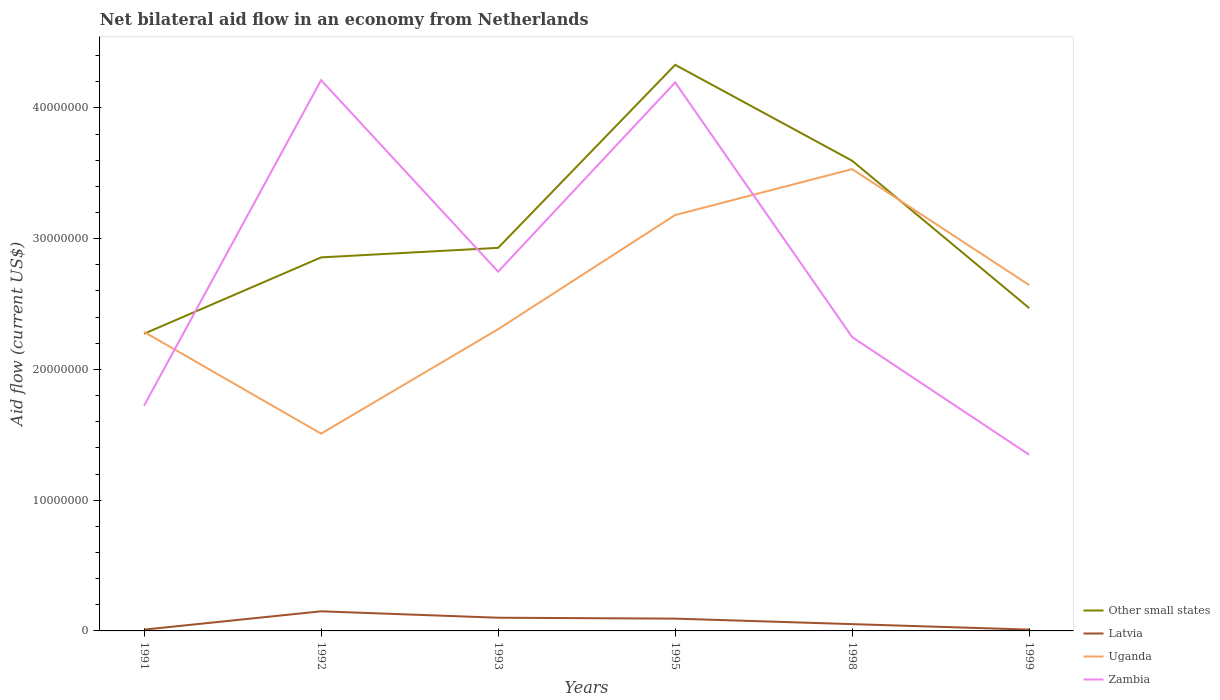Is the number of lines equal to the number of legend labels?
Your answer should be compact. Yes. What is the total net bilateral aid flow in Other small states in the graph?
Your answer should be very brief. -7.30e+05. What is the difference between the highest and the second highest net bilateral aid flow in Zambia?
Give a very brief answer. 2.87e+07. How many years are there in the graph?
Offer a very short reply. 6. Are the values on the major ticks of Y-axis written in scientific E-notation?
Offer a terse response. No. Where does the legend appear in the graph?
Your answer should be compact. Bottom right. How are the legend labels stacked?
Offer a terse response. Vertical. What is the title of the graph?
Ensure brevity in your answer.  Net bilateral aid flow in an economy from Netherlands. Does "Grenada" appear as one of the legend labels in the graph?
Ensure brevity in your answer.  No. What is the label or title of the Y-axis?
Make the answer very short. Aid flow (current US$). What is the Aid flow (current US$) of Other small states in 1991?
Give a very brief answer. 2.27e+07. What is the Aid flow (current US$) in Uganda in 1991?
Offer a terse response. 2.29e+07. What is the Aid flow (current US$) of Zambia in 1991?
Offer a terse response. 1.72e+07. What is the Aid flow (current US$) of Other small states in 1992?
Provide a short and direct response. 2.86e+07. What is the Aid flow (current US$) in Latvia in 1992?
Offer a terse response. 1.50e+06. What is the Aid flow (current US$) of Uganda in 1992?
Your answer should be compact. 1.51e+07. What is the Aid flow (current US$) in Zambia in 1992?
Keep it short and to the point. 4.21e+07. What is the Aid flow (current US$) of Other small states in 1993?
Ensure brevity in your answer.  2.93e+07. What is the Aid flow (current US$) of Latvia in 1993?
Your answer should be very brief. 1.01e+06. What is the Aid flow (current US$) in Uganda in 1993?
Offer a very short reply. 2.31e+07. What is the Aid flow (current US$) in Zambia in 1993?
Your response must be concise. 2.75e+07. What is the Aid flow (current US$) in Other small states in 1995?
Give a very brief answer. 4.33e+07. What is the Aid flow (current US$) in Latvia in 1995?
Your response must be concise. 9.40e+05. What is the Aid flow (current US$) in Uganda in 1995?
Offer a terse response. 3.18e+07. What is the Aid flow (current US$) in Zambia in 1995?
Ensure brevity in your answer.  4.20e+07. What is the Aid flow (current US$) in Other small states in 1998?
Make the answer very short. 3.60e+07. What is the Aid flow (current US$) in Latvia in 1998?
Make the answer very short. 5.20e+05. What is the Aid flow (current US$) in Uganda in 1998?
Offer a terse response. 3.53e+07. What is the Aid flow (current US$) in Zambia in 1998?
Your answer should be compact. 2.25e+07. What is the Aid flow (current US$) of Other small states in 1999?
Offer a terse response. 2.47e+07. What is the Aid flow (current US$) of Latvia in 1999?
Give a very brief answer. 1.00e+05. What is the Aid flow (current US$) in Uganda in 1999?
Offer a very short reply. 2.64e+07. What is the Aid flow (current US$) of Zambia in 1999?
Ensure brevity in your answer.  1.35e+07. Across all years, what is the maximum Aid flow (current US$) in Other small states?
Ensure brevity in your answer.  4.33e+07. Across all years, what is the maximum Aid flow (current US$) of Latvia?
Give a very brief answer. 1.50e+06. Across all years, what is the maximum Aid flow (current US$) of Uganda?
Offer a very short reply. 3.53e+07. Across all years, what is the maximum Aid flow (current US$) of Zambia?
Make the answer very short. 4.21e+07. Across all years, what is the minimum Aid flow (current US$) of Other small states?
Offer a terse response. 2.27e+07. Across all years, what is the minimum Aid flow (current US$) of Latvia?
Ensure brevity in your answer.  1.00e+05. Across all years, what is the minimum Aid flow (current US$) in Uganda?
Provide a succinct answer. 1.51e+07. Across all years, what is the minimum Aid flow (current US$) of Zambia?
Provide a short and direct response. 1.35e+07. What is the total Aid flow (current US$) in Other small states in the graph?
Your answer should be very brief. 1.85e+08. What is the total Aid flow (current US$) of Latvia in the graph?
Make the answer very short. 4.17e+06. What is the total Aid flow (current US$) in Uganda in the graph?
Provide a short and direct response. 1.55e+08. What is the total Aid flow (current US$) of Zambia in the graph?
Offer a terse response. 1.65e+08. What is the difference between the Aid flow (current US$) of Other small states in 1991 and that in 1992?
Make the answer very short. -5.84e+06. What is the difference between the Aid flow (current US$) of Latvia in 1991 and that in 1992?
Give a very brief answer. -1.40e+06. What is the difference between the Aid flow (current US$) of Uganda in 1991 and that in 1992?
Your answer should be very brief. 7.78e+06. What is the difference between the Aid flow (current US$) of Zambia in 1991 and that in 1992?
Offer a terse response. -2.49e+07. What is the difference between the Aid flow (current US$) in Other small states in 1991 and that in 1993?
Make the answer very short. -6.57e+06. What is the difference between the Aid flow (current US$) of Latvia in 1991 and that in 1993?
Offer a very short reply. -9.10e+05. What is the difference between the Aid flow (current US$) in Zambia in 1991 and that in 1993?
Your answer should be compact. -1.02e+07. What is the difference between the Aid flow (current US$) in Other small states in 1991 and that in 1995?
Your answer should be compact. -2.06e+07. What is the difference between the Aid flow (current US$) of Latvia in 1991 and that in 1995?
Provide a succinct answer. -8.40e+05. What is the difference between the Aid flow (current US$) in Uganda in 1991 and that in 1995?
Provide a succinct answer. -8.94e+06. What is the difference between the Aid flow (current US$) in Zambia in 1991 and that in 1995?
Keep it short and to the point. -2.47e+07. What is the difference between the Aid flow (current US$) of Other small states in 1991 and that in 1998?
Keep it short and to the point. -1.32e+07. What is the difference between the Aid flow (current US$) of Latvia in 1991 and that in 1998?
Give a very brief answer. -4.20e+05. What is the difference between the Aid flow (current US$) of Uganda in 1991 and that in 1998?
Give a very brief answer. -1.24e+07. What is the difference between the Aid flow (current US$) of Zambia in 1991 and that in 1998?
Provide a short and direct response. -5.24e+06. What is the difference between the Aid flow (current US$) of Other small states in 1991 and that in 1999?
Keep it short and to the point. -1.96e+06. What is the difference between the Aid flow (current US$) of Uganda in 1991 and that in 1999?
Your response must be concise. -3.58e+06. What is the difference between the Aid flow (current US$) in Zambia in 1991 and that in 1999?
Give a very brief answer. 3.76e+06. What is the difference between the Aid flow (current US$) in Other small states in 1992 and that in 1993?
Your response must be concise. -7.30e+05. What is the difference between the Aid flow (current US$) in Latvia in 1992 and that in 1993?
Offer a terse response. 4.90e+05. What is the difference between the Aid flow (current US$) of Uganda in 1992 and that in 1993?
Keep it short and to the point. -7.99e+06. What is the difference between the Aid flow (current US$) of Zambia in 1992 and that in 1993?
Offer a terse response. 1.46e+07. What is the difference between the Aid flow (current US$) in Other small states in 1992 and that in 1995?
Keep it short and to the point. -1.47e+07. What is the difference between the Aid flow (current US$) in Latvia in 1992 and that in 1995?
Your answer should be compact. 5.60e+05. What is the difference between the Aid flow (current US$) of Uganda in 1992 and that in 1995?
Ensure brevity in your answer.  -1.67e+07. What is the difference between the Aid flow (current US$) of Zambia in 1992 and that in 1995?
Provide a succinct answer. 1.80e+05. What is the difference between the Aid flow (current US$) of Other small states in 1992 and that in 1998?
Ensure brevity in your answer.  -7.39e+06. What is the difference between the Aid flow (current US$) in Latvia in 1992 and that in 1998?
Ensure brevity in your answer.  9.80e+05. What is the difference between the Aid flow (current US$) in Uganda in 1992 and that in 1998?
Make the answer very short. -2.02e+07. What is the difference between the Aid flow (current US$) in Zambia in 1992 and that in 1998?
Provide a succinct answer. 1.97e+07. What is the difference between the Aid flow (current US$) of Other small states in 1992 and that in 1999?
Give a very brief answer. 3.88e+06. What is the difference between the Aid flow (current US$) in Latvia in 1992 and that in 1999?
Make the answer very short. 1.40e+06. What is the difference between the Aid flow (current US$) in Uganda in 1992 and that in 1999?
Make the answer very short. -1.14e+07. What is the difference between the Aid flow (current US$) of Zambia in 1992 and that in 1999?
Provide a succinct answer. 2.87e+07. What is the difference between the Aid flow (current US$) of Other small states in 1993 and that in 1995?
Make the answer very short. -1.40e+07. What is the difference between the Aid flow (current US$) in Uganda in 1993 and that in 1995?
Provide a succinct answer. -8.73e+06. What is the difference between the Aid flow (current US$) of Zambia in 1993 and that in 1995?
Keep it short and to the point. -1.45e+07. What is the difference between the Aid flow (current US$) of Other small states in 1993 and that in 1998?
Give a very brief answer. -6.66e+06. What is the difference between the Aid flow (current US$) of Uganda in 1993 and that in 1998?
Make the answer very short. -1.22e+07. What is the difference between the Aid flow (current US$) of Zambia in 1993 and that in 1998?
Ensure brevity in your answer.  5.01e+06. What is the difference between the Aid flow (current US$) in Other small states in 1993 and that in 1999?
Make the answer very short. 4.61e+06. What is the difference between the Aid flow (current US$) of Latvia in 1993 and that in 1999?
Ensure brevity in your answer.  9.10e+05. What is the difference between the Aid flow (current US$) of Uganda in 1993 and that in 1999?
Your response must be concise. -3.37e+06. What is the difference between the Aid flow (current US$) in Zambia in 1993 and that in 1999?
Provide a succinct answer. 1.40e+07. What is the difference between the Aid flow (current US$) in Other small states in 1995 and that in 1998?
Your response must be concise. 7.34e+06. What is the difference between the Aid flow (current US$) in Uganda in 1995 and that in 1998?
Ensure brevity in your answer.  -3.51e+06. What is the difference between the Aid flow (current US$) in Zambia in 1995 and that in 1998?
Make the answer very short. 1.95e+07. What is the difference between the Aid flow (current US$) of Other small states in 1995 and that in 1999?
Provide a short and direct response. 1.86e+07. What is the difference between the Aid flow (current US$) in Latvia in 1995 and that in 1999?
Offer a very short reply. 8.40e+05. What is the difference between the Aid flow (current US$) of Uganda in 1995 and that in 1999?
Offer a very short reply. 5.36e+06. What is the difference between the Aid flow (current US$) in Zambia in 1995 and that in 1999?
Give a very brief answer. 2.85e+07. What is the difference between the Aid flow (current US$) of Other small states in 1998 and that in 1999?
Ensure brevity in your answer.  1.13e+07. What is the difference between the Aid flow (current US$) of Latvia in 1998 and that in 1999?
Offer a terse response. 4.20e+05. What is the difference between the Aid flow (current US$) of Uganda in 1998 and that in 1999?
Keep it short and to the point. 8.87e+06. What is the difference between the Aid flow (current US$) in Zambia in 1998 and that in 1999?
Offer a very short reply. 9.00e+06. What is the difference between the Aid flow (current US$) in Other small states in 1991 and the Aid flow (current US$) in Latvia in 1992?
Offer a terse response. 2.12e+07. What is the difference between the Aid flow (current US$) in Other small states in 1991 and the Aid flow (current US$) in Uganda in 1992?
Offer a terse response. 7.64e+06. What is the difference between the Aid flow (current US$) in Other small states in 1991 and the Aid flow (current US$) in Zambia in 1992?
Offer a terse response. -1.94e+07. What is the difference between the Aid flow (current US$) of Latvia in 1991 and the Aid flow (current US$) of Uganda in 1992?
Your response must be concise. -1.50e+07. What is the difference between the Aid flow (current US$) in Latvia in 1991 and the Aid flow (current US$) in Zambia in 1992?
Your response must be concise. -4.20e+07. What is the difference between the Aid flow (current US$) in Uganda in 1991 and the Aid flow (current US$) in Zambia in 1992?
Your answer should be compact. -1.93e+07. What is the difference between the Aid flow (current US$) in Other small states in 1991 and the Aid flow (current US$) in Latvia in 1993?
Provide a succinct answer. 2.17e+07. What is the difference between the Aid flow (current US$) in Other small states in 1991 and the Aid flow (current US$) in Uganda in 1993?
Your answer should be compact. -3.50e+05. What is the difference between the Aid flow (current US$) of Other small states in 1991 and the Aid flow (current US$) of Zambia in 1993?
Your answer should be compact. -4.75e+06. What is the difference between the Aid flow (current US$) in Latvia in 1991 and the Aid flow (current US$) in Uganda in 1993?
Your answer should be very brief. -2.30e+07. What is the difference between the Aid flow (current US$) in Latvia in 1991 and the Aid flow (current US$) in Zambia in 1993?
Your answer should be compact. -2.74e+07. What is the difference between the Aid flow (current US$) of Uganda in 1991 and the Aid flow (current US$) of Zambia in 1993?
Give a very brief answer. -4.61e+06. What is the difference between the Aid flow (current US$) in Other small states in 1991 and the Aid flow (current US$) in Latvia in 1995?
Your answer should be compact. 2.18e+07. What is the difference between the Aid flow (current US$) in Other small states in 1991 and the Aid flow (current US$) in Uganda in 1995?
Your answer should be very brief. -9.08e+06. What is the difference between the Aid flow (current US$) in Other small states in 1991 and the Aid flow (current US$) in Zambia in 1995?
Offer a very short reply. -1.92e+07. What is the difference between the Aid flow (current US$) of Latvia in 1991 and the Aid flow (current US$) of Uganda in 1995?
Make the answer very short. -3.17e+07. What is the difference between the Aid flow (current US$) in Latvia in 1991 and the Aid flow (current US$) in Zambia in 1995?
Keep it short and to the point. -4.18e+07. What is the difference between the Aid flow (current US$) of Uganda in 1991 and the Aid flow (current US$) of Zambia in 1995?
Make the answer very short. -1.91e+07. What is the difference between the Aid flow (current US$) of Other small states in 1991 and the Aid flow (current US$) of Latvia in 1998?
Make the answer very short. 2.22e+07. What is the difference between the Aid flow (current US$) of Other small states in 1991 and the Aid flow (current US$) of Uganda in 1998?
Provide a short and direct response. -1.26e+07. What is the difference between the Aid flow (current US$) of Other small states in 1991 and the Aid flow (current US$) of Zambia in 1998?
Provide a short and direct response. 2.60e+05. What is the difference between the Aid flow (current US$) of Latvia in 1991 and the Aid flow (current US$) of Uganda in 1998?
Your answer should be compact. -3.52e+07. What is the difference between the Aid flow (current US$) of Latvia in 1991 and the Aid flow (current US$) of Zambia in 1998?
Keep it short and to the point. -2.24e+07. What is the difference between the Aid flow (current US$) in Uganda in 1991 and the Aid flow (current US$) in Zambia in 1998?
Your response must be concise. 4.00e+05. What is the difference between the Aid flow (current US$) of Other small states in 1991 and the Aid flow (current US$) of Latvia in 1999?
Your answer should be very brief. 2.26e+07. What is the difference between the Aid flow (current US$) in Other small states in 1991 and the Aid flow (current US$) in Uganda in 1999?
Ensure brevity in your answer.  -3.72e+06. What is the difference between the Aid flow (current US$) in Other small states in 1991 and the Aid flow (current US$) in Zambia in 1999?
Give a very brief answer. 9.26e+06. What is the difference between the Aid flow (current US$) of Latvia in 1991 and the Aid flow (current US$) of Uganda in 1999?
Your answer should be compact. -2.64e+07. What is the difference between the Aid flow (current US$) of Latvia in 1991 and the Aid flow (current US$) of Zambia in 1999?
Your answer should be compact. -1.34e+07. What is the difference between the Aid flow (current US$) in Uganda in 1991 and the Aid flow (current US$) in Zambia in 1999?
Provide a succinct answer. 9.40e+06. What is the difference between the Aid flow (current US$) in Other small states in 1992 and the Aid flow (current US$) in Latvia in 1993?
Your answer should be very brief. 2.76e+07. What is the difference between the Aid flow (current US$) of Other small states in 1992 and the Aid flow (current US$) of Uganda in 1993?
Make the answer very short. 5.49e+06. What is the difference between the Aid flow (current US$) in Other small states in 1992 and the Aid flow (current US$) in Zambia in 1993?
Offer a terse response. 1.09e+06. What is the difference between the Aid flow (current US$) in Latvia in 1992 and the Aid flow (current US$) in Uganda in 1993?
Offer a terse response. -2.16e+07. What is the difference between the Aid flow (current US$) of Latvia in 1992 and the Aid flow (current US$) of Zambia in 1993?
Your answer should be compact. -2.60e+07. What is the difference between the Aid flow (current US$) in Uganda in 1992 and the Aid flow (current US$) in Zambia in 1993?
Ensure brevity in your answer.  -1.24e+07. What is the difference between the Aid flow (current US$) in Other small states in 1992 and the Aid flow (current US$) in Latvia in 1995?
Keep it short and to the point. 2.76e+07. What is the difference between the Aid flow (current US$) of Other small states in 1992 and the Aid flow (current US$) of Uganda in 1995?
Provide a short and direct response. -3.24e+06. What is the difference between the Aid flow (current US$) in Other small states in 1992 and the Aid flow (current US$) in Zambia in 1995?
Provide a short and direct response. -1.34e+07. What is the difference between the Aid flow (current US$) of Latvia in 1992 and the Aid flow (current US$) of Uganda in 1995?
Your response must be concise. -3.03e+07. What is the difference between the Aid flow (current US$) of Latvia in 1992 and the Aid flow (current US$) of Zambia in 1995?
Your answer should be compact. -4.04e+07. What is the difference between the Aid flow (current US$) of Uganda in 1992 and the Aid flow (current US$) of Zambia in 1995?
Provide a short and direct response. -2.69e+07. What is the difference between the Aid flow (current US$) in Other small states in 1992 and the Aid flow (current US$) in Latvia in 1998?
Make the answer very short. 2.80e+07. What is the difference between the Aid flow (current US$) in Other small states in 1992 and the Aid flow (current US$) in Uganda in 1998?
Keep it short and to the point. -6.75e+06. What is the difference between the Aid flow (current US$) in Other small states in 1992 and the Aid flow (current US$) in Zambia in 1998?
Provide a short and direct response. 6.10e+06. What is the difference between the Aid flow (current US$) of Latvia in 1992 and the Aid flow (current US$) of Uganda in 1998?
Provide a succinct answer. -3.38e+07. What is the difference between the Aid flow (current US$) of Latvia in 1992 and the Aid flow (current US$) of Zambia in 1998?
Your answer should be compact. -2.10e+07. What is the difference between the Aid flow (current US$) in Uganda in 1992 and the Aid flow (current US$) in Zambia in 1998?
Ensure brevity in your answer.  -7.38e+06. What is the difference between the Aid flow (current US$) of Other small states in 1992 and the Aid flow (current US$) of Latvia in 1999?
Your response must be concise. 2.85e+07. What is the difference between the Aid flow (current US$) of Other small states in 1992 and the Aid flow (current US$) of Uganda in 1999?
Your response must be concise. 2.12e+06. What is the difference between the Aid flow (current US$) of Other small states in 1992 and the Aid flow (current US$) of Zambia in 1999?
Offer a terse response. 1.51e+07. What is the difference between the Aid flow (current US$) of Latvia in 1992 and the Aid flow (current US$) of Uganda in 1999?
Your answer should be very brief. -2.50e+07. What is the difference between the Aid flow (current US$) of Latvia in 1992 and the Aid flow (current US$) of Zambia in 1999?
Your answer should be compact. -1.20e+07. What is the difference between the Aid flow (current US$) in Uganda in 1992 and the Aid flow (current US$) in Zambia in 1999?
Provide a short and direct response. 1.62e+06. What is the difference between the Aid flow (current US$) of Other small states in 1993 and the Aid flow (current US$) of Latvia in 1995?
Offer a terse response. 2.84e+07. What is the difference between the Aid flow (current US$) of Other small states in 1993 and the Aid flow (current US$) of Uganda in 1995?
Your response must be concise. -2.51e+06. What is the difference between the Aid flow (current US$) in Other small states in 1993 and the Aid flow (current US$) in Zambia in 1995?
Offer a very short reply. -1.26e+07. What is the difference between the Aid flow (current US$) of Latvia in 1993 and the Aid flow (current US$) of Uganda in 1995?
Give a very brief answer. -3.08e+07. What is the difference between the Aid flow (current US$) in Latvia in 1993 and the Aid flow (current US$) in Zambia in 1995?
Offer a very short reply. -4.09e+07. What is the difference between the Aid flow (current US$) of Uganda in 1993 and the Aid flow (current US$) of Zambia in 1995?
Make the answer very short. -1.89e+07. What is the difference between the Aid flow (current US$) in Other small states in 1993 and the Aid flow (current US$) in Latvia in 1998?
Ensure brevity in your answer.  2.88e+07. What is the difference between the Aid flow (current US$) in Other small states in 1993 and the Aid flow (current US$) in Uganda in 1998?
Provide a succinct answer. -6.02e+06. What is the difference between the Aid flow (current US$) of Other small states in 1993 and the Aid flow (current US$) of Zambia in 1998?
Your answer should be very brief. 6.83e+06. What is the difference between the Aid flow (current US$) in Latvia in 1993 and the Aid flow (current US$) in Uganda in 1998?
Offer a very short reply. -3.43e+07. What is the difference between the Aid flow (current US$) in Latvia in 1993 and the Aid flow (current US$) in Zambia in 1998?
Ensure brevity in your answer.  -2.15e+07. What is the difference between the Aid flow (current US$) in Other small states in 1993 and the Aid flow (current US$) in Latvia in 1999?
Offer a very short reply. 2.92e+07. What is the difference between the Aid flow (current US$) in Other small states in 1993 and the Aid flow (current US$) in Uganda in 1999?
Provide a short and direct response. 2.85e+06. What is the difference between the Aid flow (current US$) of Other small states in 1993 and the Aid flow (current US$) of Zambia in 1999?
Provide a short and direct response. 1.58e+07. What is the difference between the Aid flow (current US$) in Latvia in 1993 and the Aid flow (current US$) in Uganda in 1999?
Give a very brief answer. -2.54e+07. What is the difference between the Aid flow (current US$) of Latvia in 1993 and the Aid flow (current US$) of Zambia in 1999?
Keep it short and to the point. -1.25e+07. What is the difference between the Aid flow (current US$) of Uganda in 1993 and the Aid flow (current US$) of Zambia in 1999?
Your response must be concise. 9.61e+06. What is the difference between the Aid flow (current US$) of Other small states in 1995 and the Aid flow (current US$) of Latvia in 1998?
Make the answer very short. 4.28e+07. What is the difference between the Aid flow (current US$) in Other small states in 1995 and the Aid flow (current US$) in Uganda in 1998?
Ensure brevity in your answer.  7.98e+06. What is the difference between the Aid flow (current US$) in Other small states in 1995 and the Aid flow (current US$) in Zambia in 1998?
Your response must be concise. 2.08e+07. What is the difference between the Aid flow (current US$) of Latvia in 1995 and the Aid flow (current US$) of Uganda in 1998?
Your answer should be compact. -3.44e+07. What is the difference between the Aid flow (current US$) of Latvia in 1995 and the Aid flow (current US$) of Zambia in 1998?
Your answer should be very brief. -2.15e+07. What is the difference between the Aid flow (current US$) in Uganda in 1995 and the Aid flow (current US$) in Zambia in 1998?
Your answer should be compact. 9.34e+06. What is the difference between the Aid flow (current US$) of Other small states in 1995 and the Aid flow (current US$) of Latvia in 1999?
Provide a short and direct response. 4.32e+07. What is the difference between the Aid flow (current US$) of Other small states in 1995 and the Aid flow (current US$) of Uganda in 1999?
Your response must be concise. 1.68e+07. What is the difference between the Aid flow (current US$) of Other small states in 1995 and the Aid flow (current US$) of Zambia in 1999?
Offer a terse response. 2.98e+07. What is the difference between the Aid flow (current US$) of Latvia in 1995 and the Aid flow (current US$) of Uganda in 1999?
Your answer should be compact. -2.55e+07. What is the difference between the Aid flow (current US$) in Latvia in 1995 and the Aid flow (current US$) in Zambia in 1999?
Your answer should be very brief. -1.25e+07. What is the difference between the Aid flow (current US$) in Uganda in 1995 and the Aid flow (current US$) in Zambia in 1999?
Offer a very short reply. 1.83e+07. What is the difference between the Aid flow (current US$) of Other small states in 1998 and the Aid flow (current US$) of Latvia in 1999?
Offer a very short reply. 3.59e+07. What is the difference between the Aid flow (current US$) in Other small states in 1998 and the Aid flow (current US$) in Uganda in 1999?
Offer a very short reply. 9.51e+06. What is the difference between the Aid flow (current US$) of Other small states in 1998 and the Aid flow (current US$) of Zambia in 1999?
Provide a short and direct response. 2.25e+07. What is the difference between the Aid flow (current US$) of Latvia in 1998 and the Aid flow (current US$) of Uganda in 1999?
Give a very brief answer. -2.59e+07. What is the difference between the Aid flow (current US$) of Latvia in 1998 and the Aid flow (current US$) of Zambia in 1999?
Provide a short and direct response. -1.30e+07. What is the difference between the Aid flow (current US$) in Uganda in 1998 and the Aid flow (current US$) in Zambia in 1999?
Your answer should be very brief. 2.18e+07. What is the average Aid flow (current US$) of Other small states per year?
Ensure brevity in your answer.  3.08e+07. What is the average Aid flow (current US$) in Latvia per year?
Your response must be concise. 6.95e+05. What is the average Aid flow (current US$) of Uganda per year?
Offer a terse response. 2.58e+07. What is the average Aid flow (current US$) of Zambia per year?
Your response must be concise. 2.75e+07. In the year 1991, what is the difference between the Aid flow (current US$) in Other small states and Aid flow (current US$) in Latvia?
Provide a succinct answer. 2.26e+07. In the year 1991, what is the difference between the Aid flow (current US$) of Other small states and Aid flow (current US$) of Uganda?
Make the answer very short. -1.40e+05. In the year 1991, what is the difference between the Aid flow (current US$) in Other small states and Aid flow (current US$) in Zambia?
Your response must be concise. 5.50e+06. In the year 1991, what is the difference between the Aid flow (current US$) of Latvia and Aid flow (current US$) of Uganda?
Offer a terse response. -2.28e+07. In the year 1991, what is the difference between the Aid flow (current US$) of Latvia and Aid flow (current US$) of Zambia?
Your response must be concise. -1.71e+07. In the year 1991, what is the difference between the Aid flow (current US$) in Uganda and Aid flow (current US$) in Zambia?
Provide a short and direct response. 5.64e+06. In the year 1992, what is the difference between the Aid flow (current US$) of Other small states and Aid flow (current US$) of Latvia?
Your answer should be compact. 2.71e+07. In the year 1992, what is the difference between the Aid flow (current US$) in Other small states and Aid flow (current US$) in Uganda?
Offer a terse response. 1.35e+07. In the year 1992, what is the difference between the Aid flow (current US$) in Other small states and Aid flow (current US$) in Zambia?
Offer a terse response. -1.36e+07. In the year 1992, what is the difference between the Aid flow (current US$) in Latvia and Aid flow (current US$) in Uganda?
Offer a terse response. -1.36e+07. In the year 1992, what is the difference between the Aid flow (current US$) in Latvia and Aid flow (current US$) in Zambia?
Your answer should be compact. -4.06e+07. In the year 1992, what is the difference between the Aid flow (current US$) in Uganda and Aid flow (current US$) in Zambia?
Your response must be concise. -2.70e+07. In the year 1993, what is the difference between the Aid flow (current US$) of Other small states and Aid flow (current US$) of Latvia?
Ensure brevity in your answer.  2.83e+07. In the year 1993, what is the difference between the Aid flow (current US$) of Other small states and Aid flow (current US$) of Uganda?
Offer a very short reply. 6.22e+06. In the year 1993, what is the difference between the Aid flow (current US$) of Other small states and Aid flow (current US$) of Zambia?
Keep it short and to the point. 1.82e+06. In the year 1993, what is the difference between the Aid flow (current US$) of Latvia and Aid flow (current US$) of Uganda?
Offer a terse response. -2.21e+07. In the year 1993, what is the difference between the Aid flow (current US$) in Latvia and Aid flow (current US$) in Zambia?
Ensure brevity in your answer.  -2.65e+07. In the year 1993, what is the difference between the Aid flow (current US$) in Uganda and Aid flow (current US$) in Zambia?
Provide a short and direct response. -4.40e+06. In the year 1995, what is the difference between the Aid flow (current US$) in Other small states and Aid flow (current US$) in Latvia?
Your answer should be compact. 4.24e+07. In the year 1995, what is the difference between the Aid flow (current US$) in Other small states and Aid flow (current US$) in Uganda?
Offer a very short reply. 1.15e+07. In the year 1995, what is the difference between the Aid flow (current US$) of Other small states and Aid flow (current US$) of Zambia?
Your answer should be very brief. 1.35e+06. In the year 1995, what is the difference between the Aid flow (current US$) in Latvia and Aid flow (current US$) in Uganda?
Make the answer very short. -3.09e+07. In the year 1995, what is the difference between the Aid flow (current US$) in Latvia and Aid flow (current US$) in Zambia?
Make the answer very short. -4.10e+07. In the year 1995, what is the difference between the Aid flow (current US$) of Uganda and Aid flow (current US$) of Zambia?
Give a very brief answer. -1.01e+07. In the year 1998, what is the difference between the Aid flow (current US$) of Other small states and Aid flow (current US$) of Latvia?
Your answer should be very brief. 3.54e+07. In the year 1998, what is the difference between the Aid flow (current US$) of Other small states and Aid flow (current US$) of Uganda?
Your response must be concise. 6.40e+05. In the year 1998, what is the difference between the Aid flow (current US$) of Other small states and Aid flow (current US$) of Zambia?
Ensure brevity in your answer.  1.35e+07. In the year 1998, what is the difference between the Aid flow (current US$) in Latvia and Aid flow (current US$) in Uganda?
Make the answer very short. -3.48e+07. In the year 1998, what is the difference between the Aid flow (current US$) in Latvia and Aid flow (current US$) in Zambia?
Make the answer very short. -2.20e+07. In the year 1998, what is the difference between the Aid flow (current US$) in Uganda and Aid flow (current US$) in Zambia?
Offer a terse response. 1.28e+07. In the year 1999, what is the difference between the Aid flow (current US$) of Other small states and Aid flow (current US$) of Latvia?
Ensure brevity in your answer.  2.46e+07. In the year 1999, what is the difference between the Aid flow (current US$) in Other small states and Aid flow (current US$) in Uganda?
Your answer should be compact. -1.76e+06. In the year 1999, what is the difference between the Aid flow (current US$) in Other small states and Aid flow (current US$) in Zambia?
Offer a very short reply. 1.12e+07. In the year 1999, what is the difference between the Aid flow (current US$) of Latvia and Aid flow (current US$) of Uganda?
Offer a terse response. -2.64e+07. In the year 1999, what is the difference between the Aid flow (current US$) of Latvia and Aid flow (current US$) of Zambia?
Your answer should be very brief. -1.34e+07. In the year 1999, what is the difference between the Aid flow (current US$) of Uganda and Aid flow (current US$) of Zambia?
Offer a terse response. 1.30e+07. What is the ratio of the Aid flow (current US$) of Other small states in 1991 to that in 1992?
Your response must be concise. 0.8. What is the ratio of the Aid flow (current US$) of Latvia in 1991 to that in 1992?
Offer a terse response. 0.07. What is the ratio of the Aid flow (current US$) of Uganda in 1991 to that in 1992?
Your response must be concise. 1.52. What is the ratio of the Aid flow (current US$) of Zambia in 1991 to that in 1992?
Offer a very short reply. 0.41. What is the ratio of the Aid flow (current US$) of Other small states in 1991 to that in 1993?
Offer a very short reply. 0.78. What is the ratio of the Aid flow (current US$) in Latvia in 1991 to that in 1993?
Offer a terse response. 0.1. What is the ratio of the Aid flow (current US$) of Uganda in 1991 to that in 1993?
Your answer should be very brief. 0.99. What is the ratio of the Aid flow (current US$) in Zambia in 1991 to that in 1993?
Make the answer very short. 0.63. What is the ratio of the Aid flow (current US$) of Other small states in 1991 to that in 1995?
Offer a terse response. 0.52. What is the ratio of the Aid flow (current US$) of Latvia in 1991 to that in 1995?
Ensure brevity in your answer.  0.11. What is the ratio of the Aid flow (current US$) of Uganda in 1991 to that in 1995?
Your answer should be very brief. 0.72. What is the ratio of the Aid flow (current US$) in Zambia in 1991 to that in 1995?
Provide a succinct answer. 0.41. What is the ratio of the Aid flow (current US$) in Other small states in 1991 to that in 1998?
Keep it short and to the point. 0.63. What is the ratio of the Aid flow (current US$) of Latvia in 1991 to that in 1998?
Offer a terse response. 0.19. What is the ratio of the Aid flow (current US$) in Uganda in 1991 to that in 1998?
Your response must be concise. 0.65. What is the ratio of the Aid flow (current US$) in Zambia in 1991 to that in 1998?
Make the answer very short. 0.77. What is the ratio of the Aid flow (current US$) in Other small states in 1991 to that in 1999?
Keep it short and to the point. 0.92. What is the ratio of the Aid flow (current US$) of Uganda in 1991 to that in 1999?
Ensure brevity in your answer.  0.86. What is the ratio of the Aid flow (current US$) of Zambia in 1991 to that in 1999?
Ensure brevity in your answer.  1.28. What is the ratio of the Aid flow (current US$) in Other small states in 1992 to that in 1993?
Make the answer very short. 0.98. What is the ratio of the Aid flow (current US$) in Latvia in 1992 to that in 1993?
Offer a very short reply. 1.49. What is the ratio of the Aid flow (current US$) of Uganda in 1992 to that in 1993?
Give a very brief answer. 0.65. What is the ratio of the Aid flow (current US$) in Zambia in 1992 to that in 1993?
Offer a terse response. 1.53. What is the ratio of the Aid flow (current US$) of Other small states in 1992 to that in 1995?
Keep it short and to the point. 0.66. What is the ratio of the Aid flow (current US$) of Latvia in 1992 to that in 1995?
Ensure brevity in your answer.  1.6. What is the ratio of the Aid flow (current US$) of Uganda in 1992 to that in 1995?
Your response must be concise. 0.47. What is the ratio of the Aid flow (current US$) in Zambia in 1992 to that in 1995?
Ensure brevity in your answer.  1. What is the ratio of the Aid flow (current US$) in Other small states in 1992 to that in 1998?
Offer a very short reply. 0.79. What is the ratio of the Aid flow (current US$) in Latvia in 1992 to that in 1998?
Your answer should be very brief. 2.88. What is the ratio of the Aid flow (current US$) in Uganda in 1992 to that in 1998?
Offer a very short reply. 0.43. What is the ratio of the Aid flow (current US$) of Zambia in 1992 to that in 1998?
Provide a succinct answer. 1.87. What is the ratio of the Aid flow (current US$) of Other small states in 1992 to that in 1999?
Give a very brief answer. 1.16. What is the ratio of the Aid flow (current US$) of Uganda in 1992 to that in 1999?
Offer a terse response. 0.57. What is the ratio of the Aid flow (current US$) of Zambia in 1992 to that in 1999?
Your response must be concise. 3.13. What is the ratio of the Aid flow (current US$) in Other small states in 1993 to that in 1995?
Your answer should be very brief. 0.68. What is the ratio of the Aid flow (current US$) in Latvia in 1993 to that in 1995?
Provide a short and direct response. 1.07. What is the ratio of the Aid flow (current US$) of Uganda in 1993 to that in 1995?
Provide a succinct answer. 0.73. What is the ratio of the Aid flow (current US$) in Zambia in 1993 to that in 1995?
Ensure brevity in your answer.  0.66. What is the ratio of the Aid flow (current US$) in Other small states in 1993 to that in 1998?
Provide a succinct answer. 0.81. What is the ratio of the Aid flow (current US$) of Latvia in 1993 to that in 1998?
Keep it short and to the point. 1.94. What is the ratio of the Aid flow (current US$) in Uganda in 1993 to that in 1998?
Make the answer very short. 0.65. What is the ratio of the Aid flow (current US$) in Zambia in 1993 to that in 1998?
Keep it short and to the point. 1.22. What is the ratio of the Aid flow (current US$) of Other small states in 1993 to that in 1999?
Ensure brevity in your answer.  1.19. What is the ratio of the Aid flow (current US$) of Uganda in 1993 to that in 1999?
Your answer should be very brief. 0.87. What is the ratio of the Aid flow (current US$) of Zambia in 1993 to that in 1999?
Ensure brevity in your answer.  2.04. What is the ratio of the Aid flow (current US$) in Other small states in 1995 to that in 1998?
Your answer should be compact. 1.2. What is the ratio of the Aid flow (current US$) in Latvia in 1995 to that in 1998?
Your response must be concise. 1.81. What is the ratio of the Aid flow (current US$) of Uganda in 1995 to that in 1998?
Provide a succinct answer. 0.9. What is the ratio of the Aid flow (current US$) of Zambia in 1995 to that in 1998?
Make the answer very short. 1.87. What is the ratio of the Aid flow (current US$) in Other small states in 1995 to that in 1999?
Ensure brevity in your answer.  1.75. What is the ratio of the Aid flow (current US$) in Uganda in 1995 to that in 1999?
Offer a terse response. 1.2. What is the ratio of the Aid flow (current US$) of Zambia in 1995 to that in 1999?
Offer a terse response. 3.11. What is the ratio of the Aid flow (current US$) in Other small states in 1998 to that in 1999?
Offer a very short reply. 1.46. What is the ratio of the Aid flow (current US$) in Latvia in 1998 to that in 1999?
Give a very brief answer. 5.2. What is the ratio of the Aid flow (current US$) in Uganda in 1998 to that in 1999?
Offer a very short reply. 1.34. What is the ratio of the Aid flow (current US$) of Zambia in 1998 to that in 1999?
Provide a succinct answer. 1.67. What is the difference between the highest and the second highest Aid flow (current US$) of Other small states?
Your answer should be compact. 7.34e+06. What is the difference between the highest and the second highest Aid flow (current US$) of Uganda?
Your response must be concise. 3.51e+06. What is the difference between the highest and the lowest Aid flow (current US$) in Other small states?
Make the answer very short. 2.06e+07. What is the difference between the highest and the lowest Aid flow (current US$) in Latvia?
Ensure brevity in your answer.  1.40e+06. What is the difference between the highest and the lowest Aid flow (current US$) in Uganda?
Keep it short and to the point. 2.02e+07. What is the difference between the highest and the lowest Aid flow (current US$) in Zambia?
Provide a short and direct response. 2.87e+07. 